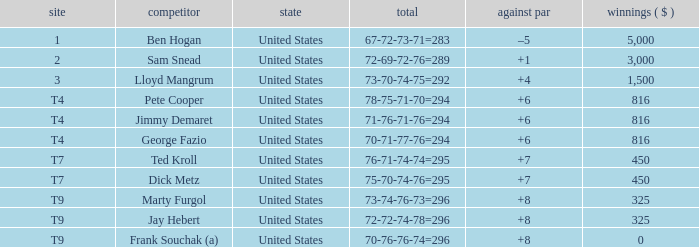What was Marty Furgol's place when he was paid less than $3,000? T9. 